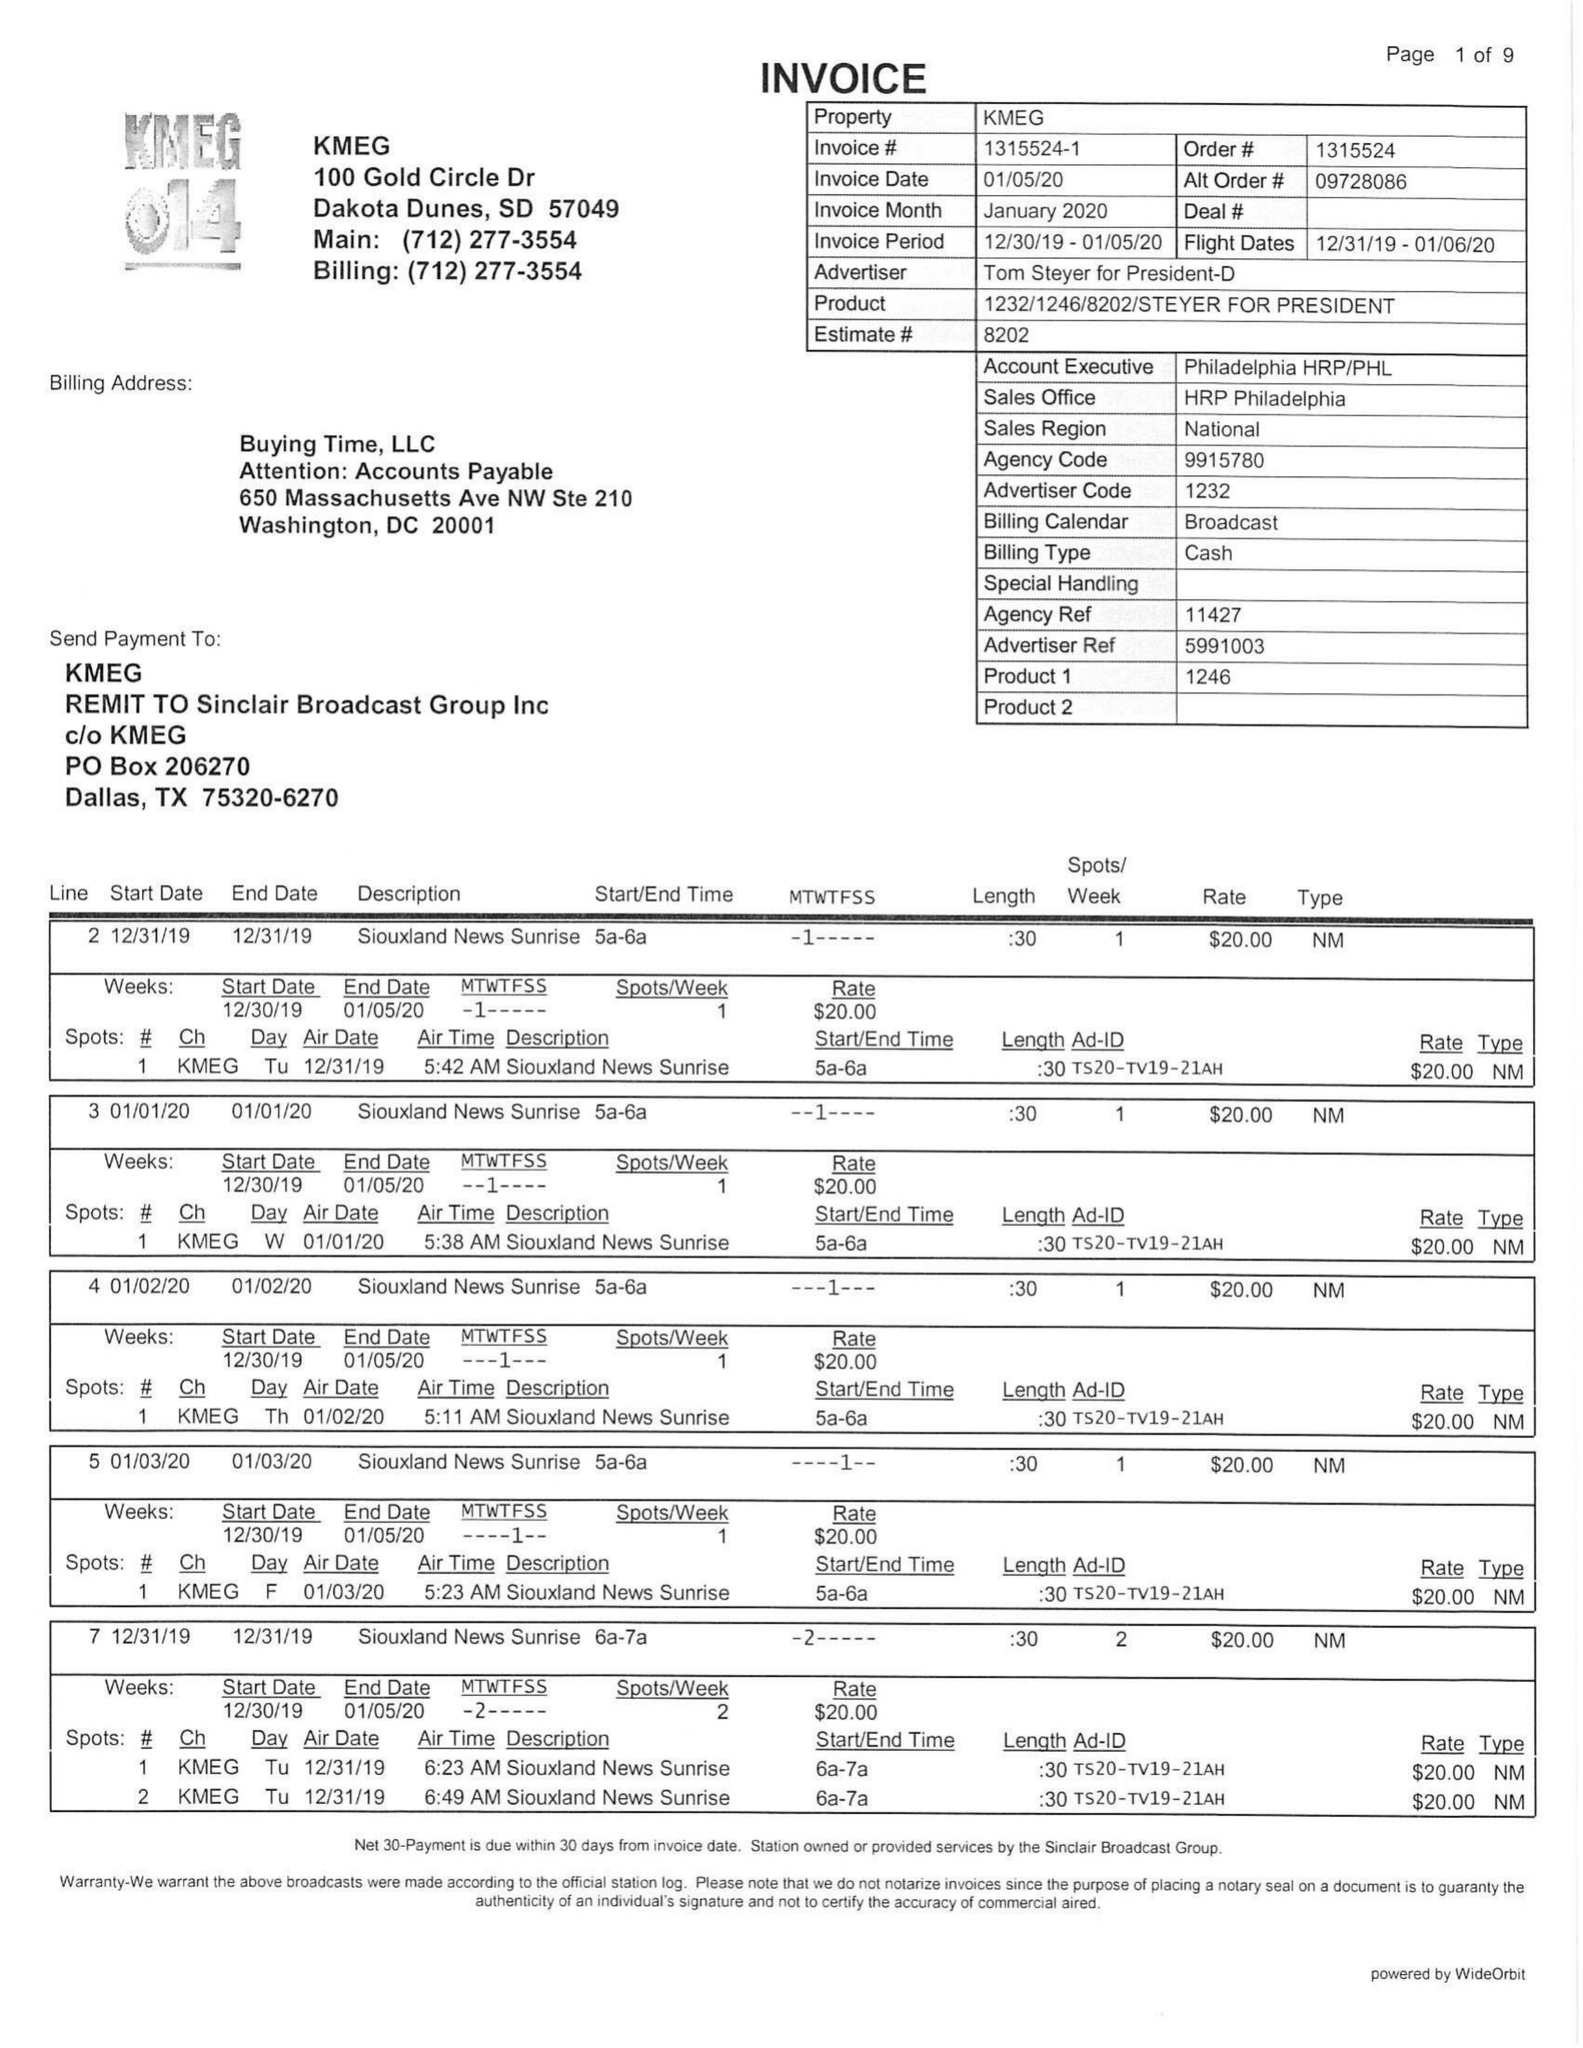What is the value for the gross_amount?
Answer the question using a single word or phrase. 4055.00 